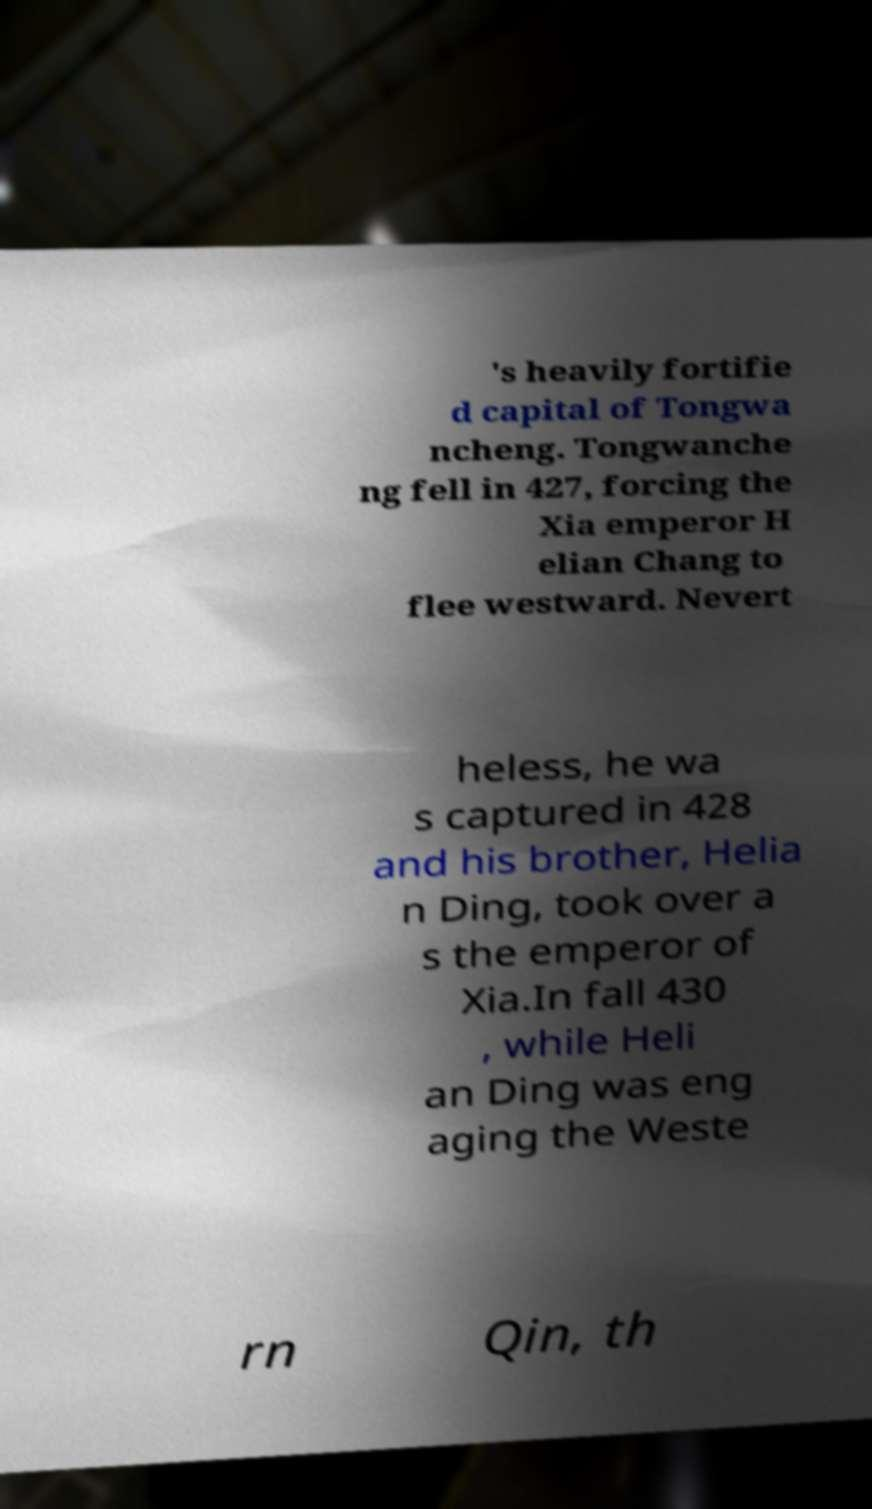What messages or text are displayed in this image? I need them in a readable, typed format. 's heavily fortifie d capital of Tongwa ncheng. Tongwanche ng fell in 427, forcing the Xia emperor H elian Chang to flee westward. Nevert heless, he wa s captured in 428 and his brother, Helia n Ding, took over a s the emperor of Xia.In fall 430 , while Heli an Ding was eng aging the Weste rn Qin, th 